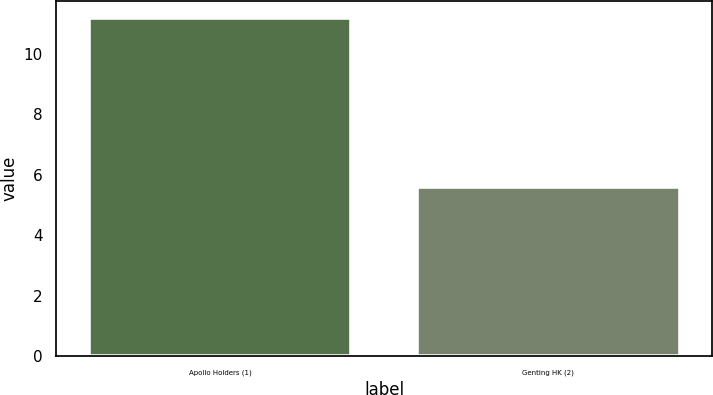Convert chart. <chart><loc_0><loc_0><loc_500><loc_500><bar_chart><fcel>Apollo Holders (1)<fcel>Genting HK (2)<nl><fcel>11.2<fcel>5.6<nl></chart> 